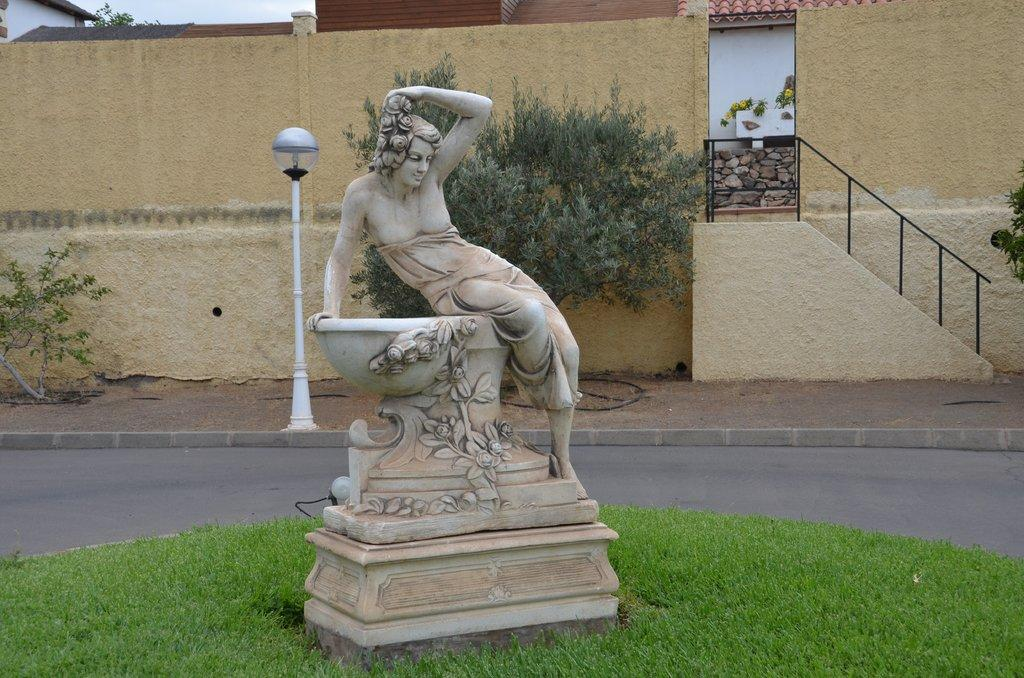What is the main subject of the image? There is a statue of a person in the image. What can be seen in the background of the image? In the background of the image, there are plants, grass, a pole light, a wall, and the sky. Can you describe the other objects present in the image? There are other objects present in the image, but their specific details are not mentioned in the provided facts. What type of friction can be observed between the statue and the ground in the image? There is no information about friction between the statue and the ground in the image. What holiday is being celebrated in the image? There is no indication of a holiday being celebrated in the image. Can you see any geese in the image? There is no mention of geese in the image. 